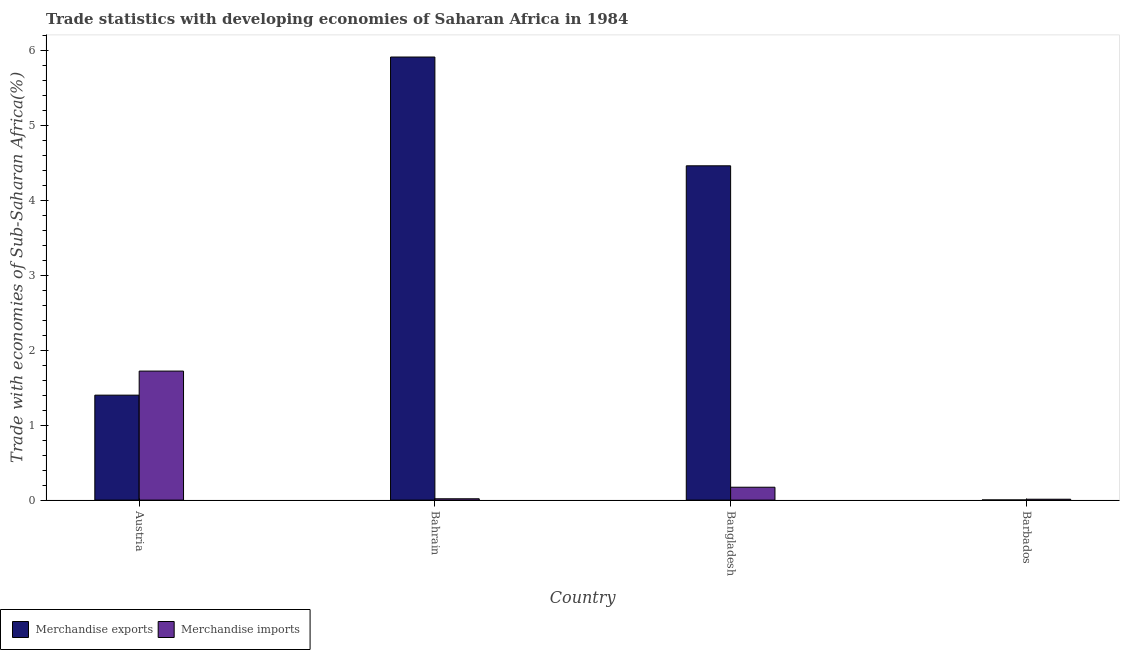Are the number of bars on each tick of the X-axis equal?
Provide a short and direct response. Yes. How many bars are there on the 4th tick from the left?
Offer a very short reply. 2. How many bars are there on the 4th tick from the right?
Your answer should be compact. 2. What is the label of the 4th group of bars from the left?
Offer a terse response. Barbados. What is the merchandise exports in Barbados?
Ensure brevity in your answer.  0. Across all countries, what is the maximum merchandise imports?
Give a very brief answer. 1.72. Across all countries, what is the minimum merchandise exports?
Your answer should be very brief. 0. In which country was the merchandise exports minimum?
Keep it short and to the point. Barbados. What is the total merchandise imports in the graph?
Your answer should be compact. 1.92. What is the difference between the merchandise exports in Austria and that in Bahrain?
Offer a very short reply. -4.51. What is the difference between the merchandise imports in Bangladesh and the merchandise exports in Bahrain?
Provide a succinct answer. -5.74. What is the average merchandise imports per country?
Give a very brief answer. 0.48. What is the difference between the merchandise imports and merchandise exports in Bahrain?
Keep it short and to the point. -5.89. What is the ratio of the merchandise exports in Bahrain to that in Barbados?
Your answer should be very brief. 3288.36. Is the merchandise imports in Bahrain less than that in Barbados?
Keep it short and to the point. No. What is the difference between the highest and the second highest merchandise exports?
Ensure brevity in your answer.  1.45. What is the difference between the highest and the lowest merchandise exports?
Provide a short and direct response. 5.9. Is the sum of the merchandise imports in Austria and Bangladesh greater than the maximum merchandise exports across all countries?
Give a very brief answer. No. What does the 1st bar from the left in Austria represents?
Give a very brief answer. Merchandise exports. How many bars are there?
Your answer should be compact. 8. How many countries are there in the graph?
Offer a very short reply. 4. Are the values on the major ticks of Y-axis written in scientific E-notation?
Provide a short and direct response. No. How many legend labels are there?
Your answer should be very brief. 2. How are the legend labels stacked?
Keep it short and to the point. Horizontal. What is the title of the graph?
Provide a short and direct response. Trade statistics with developing economies of Saharan Africa in 1984. What is the label or title of the Y-axis?
Provide a short and direct response. Trade with economies of Sub-Saharan Africa(%). What is the Trade with economies of Sub-Saharan Africa(%) in Merchandise exports in Austria?
Keep it short and to the point. 1.4. What is the Trade with economies of Sub-Saharan Africa(%) of Merchandise imports in Austria?
Keep it short and to the point. 1.72. What is the Trade with economies of Sub-Saharan Africa(%) in Merchandise exports in Bahrain?
Your response must be concise. 5.91. What is the Trade with economies of Sub-Saharan Africa(%) in Merchandise imports in Bahrain?
Ensure brevity in your answer.  0.02. What is the Trade with economies of Sub-Saharan Africa(%) of Merchandise exports in Bangladesh?
Your response must be concise. 4.46. What is the Trade with economies of Sub-Saharan Africa(%) in Merchandise imports in Bangladesh?
Give a very brief answer. 0.17. What is the Trade with economies of Sub-Saharan Africa(%) of Merchandise exports in Barbados?
Offer a very short reply. 0. What is the Trade with economies of Sub-Saharan Africa(%) in Merchandise imports in Barbados?
Keep it short and to the point. 0.01. Across all countries, what is the maximum Trade with economies of Sub-Saharan Africa(%) of Merchandise exports?
Offer a very short reply. 5.91. Across all countries, what is the maximum Trade with economies of Sub-Saharan Africa(%) of Merchandise imports?
Your answer should be very brief. 1.72. Across all countries, what is the minimum Trade with economies of Sub-Saharan Africa(%) in Merchandise exports?
Offer a very short reply. 0. Across all countries, what is the minimum Trade with economies of Sub-Saharan Africa(%) of Merchandise imports?
Make the answer very short. 0.01. What is the total Trade with economies of Sub-Saharan Africa(%) in Merchandise exports in the graph?
Your answer should be very brief. 11.76. What is the total Trade with economies of Sub-Saharan Africa(%) in Merchandise imports in the graph?
Give a very brief answer. 1.92. What is the difference between the Trade with economies of Sub-Saharan Africa(%) in Merchandise exports in Austria and that in Bahrain?
Provide a short and direct response. -4.51. What is the difference between the Trade with economies of Sub-Saharan Africa(%) of Merchandise imports in Austria and that in Bahrain?
Ensure brevity in your answer.  1.7. What is the difference between the Trade with economies of Sub-Saharan Africa(%) in Merchandise exports in Austria and that in Bangladesh?
Your answer should be compact. -3.06. What is the difference between the Trade with economies of Sub-Saharan Africa(%) of Merchandise imports in Austria and that in Bangladesh?
Provide a short and direct response. 1.55. What is the difference between the Trade with economies of Sub-Saharan Africa(%) of Merchandise exports in Austria and that in Barbados?
Provide a succinct answer. 1.4. What is the difference between the Trade with economies of Sub-Saharan Africa(%) in Merchandise imports in Austria and that in Barbados?
Give a very brief answer. 1.71. What is the difference between the Trade with economies of Sub-Saharan Africa(%) of Merchandise exports in Bahrain and that in Bangladesh?
Provide a succinct answer. 1.45. What is the difference between the Trade with economies of Sub-Saharan Africa(%) in Merchandise imports in Bahrain and that in Bangladesh?
Your answer should be compact. -0.15. What is the difference between the Trade with economies of Sub-Saharan Africa(%) of Merchandise exports in Bahrain and that in Barbados?
Your answer should be compact. 5.9. What is the difference between the Trade with economies of Sub-Saharan Africa(%) in Merchandise imports in Bahrain and that in Barbados?
Give a very brief answer. 0.01. What is the difference between the Trade with economies of Sub-Saharan Africa(%) in Merchandise exports in Bangladesh and that in Barbados?
Make the answer very short. 4.45. What is the difference between the Trade with economies of Sub-Saharan Africa(%) in Merchandise imports in Bangladesh and that in Barbados?
Keep it short and to the point. 0.16. What is the difference between the Trade with economies of Sub-Saharan Africa(%) in Merchandise exports in Austria and the Trade with economies of Sub-Saharan Africa(%) in Merchandise imports in Bahrain?
Offer a very short reply. 1.38. What is the difference between the Trade with economies of Sub-Saharan Africa(%) of Merchandise exports in Austria and the Trade with economies of Sub-Saharan Africa(%) of Merchandise imports in Bangladesh?
Your response must be concise. 1.23. What is the difference between the Trade with economies of Sub-Saharan Africa(%) in Merchandise exports in Austria and the Trade with economies of Sub-Saharan Africa(%) in Merchandise imports in Barbados?
Provide a short and direct response. 1.39. What is the difference between the Trade with economies of Sub-Saharan Africa(%) in Merchandise exports in Bahrain and the Trade with economies of Sub-Saharan Africa(%) in Merchandise imports in Bangladesh?
Your response must be concise. 5.74. What is the difference between the Trade with economies of Sub-Saharan Africa(%) of Merchandise exports in Bahrain and the Trade with economies of Sub-Saharan Africa(%) of Merchandise imports in Barbados?
Make the answer very short. 5.9. What is the difference between the Trade with economies of Sub-Saharan Africa(%) of Merchandise exports in Bangladesh and the Trade with economies of Sub-Saharan Africa(%) of Merchandise imports in Barbados?
Your answer should be compact. 4.45. What is the average Trade with economies of Sub-Saharan Africa(%) in Merchandise exports per country?
Provide a succinct answer. 2.94. What is the average Trade with economies of Sub-Saharan Africa(%) of Merchandise imports per country?
Provide a succinct answer. 0.48. What is the difference between the Trade with economies of Sub-Saharan Africa(%) in Merchandise exports and Trade with economies of Sub-Saharan Africa(%) in Merchandise imports in Austria?
Make the answer very short. -0.32. What is the difference between the Trade with economies of Sub-Saharan Africa(%) in Merchandise exports and Trade with economies of Sub-Saharan Africa(%) in Merchandise imports in Bahrain?
Keep it short and to the point. 5.89. What is the difference between the Trade with economies of Sub-Saharan Africa(%) of Merchandise exports and Trade with economies of Sub-Saharan Africa(%) of Merchandise imports in Bangladesh?
Your answer should be compact. 4.29. What is the difference between the Trade with economies of Sub-Saharan Africa(%) of Merchandise exports and Trade with economies of Sub-Saharan Africa(%) of Merchandise imports in Barbados?
Your response must be concise. -0.01. What is the ratio of the Trade with economies of Sub-Saharan Africa(%) in Merchandise exports in Austria to that in Bahrain?
Give a very brief answer. 0.24. What is the ratio of the Trade with economies of Sub-Saharan Africa(%) of Merchandise imports in Austria to that in Bahrain?
Give a very brief answer. 97.75. What is the ratio of the Trade with economies of Sub-Saharan Africa(%) in Merchandise exports in Austria to that in Bangladesh?
Your response must be concise. 0.31. What is the ratio of the Trade with economies of Sub-Saharan Africa(%) in Merchandise imports in Austria to that in Bangladesh?
Provide a short and direct response. 10.03. What is the ratio of the Trade with economies of Sub-Saharan Africa(%) in Merchandise exports in Austria to that in Barbados?
Your answer should be compact. 778.93. What is the ratio of the Trade with economies of Sub-Saharan Africa(%) in Merchandise imports in Austria to that in Barbados?
Provide a succinct answer. 148.67. What is the ratio of the Trade with economies of Sub-Saharan Africa(%) in Merchandise exports in Bahrain to that in Bangladesh?
Provide a succinct answer. 1.33. What is the ratio of the Trade with economies of Sub-Saharan Africa(%) of Merchandise imports in Bahrain to that in Bangladesh?
Offer a terse response. 0.1. What is the ratio of the Trade with economies of Sub-Saharan Africa(%) in Merchandise exports in Bahrain to that in Barbados?
Ensure brevity in your answer.  3288.36. What is the ratio of the Trade with economies of Sub-Saharan Africa(%) in Merchandise imports in Bahrain to that in Barbados?
Your answer should be compact. 1.52. What is the ratio of the Trade with economies of Sub-Saharan Africa(%) in Merchandise exports in Bangladesh to that in Barbados?
Your answer should be very brief. 2481.03. What is the ratio of the Trade with economies of Sub-Saharan Africa(%) in Merchandise imports in Bangladesh to that in Barbados?
Give a very brief answer. 14.83. What is the difference between the highest and the second highest Trade with economies of Sub-Saharan Africa(%) of Merchandise exports?
Provide a short and direct response. 1.45. What is the difference between the highest and the second highest Trade with economies of Sub-Saharan Africa(%) in Merchandise imports?
Provide a short and direct response. 1.55. What is the difference between the highest and the lowest Trade with economies of Sub-Saharan Africa(%) of Merchandise exports?
Your response must be concise. 5.9. What is the difference between the highest and the lowest Trade with economies of Sub-Saharan Africa(%) in Merchandise imports?
Keep it short and to the point. 1.71. 